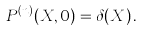<formula> <loc_0><loc_0><loc_500><loc_500>P ^ { ( n ) } ( X , 0 ) = \delta ( X ) \, .</formula> 